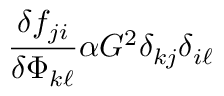Convert formula to latex. <formula><loc_0><loc_0><loc_500><loc_500>\frac { \delta f _ { j i } } { \delta \Phi _ { k \ell } } \alpha G ^ { 2 } \delta _ { k j } \delta _ { i \ell }</formula> 